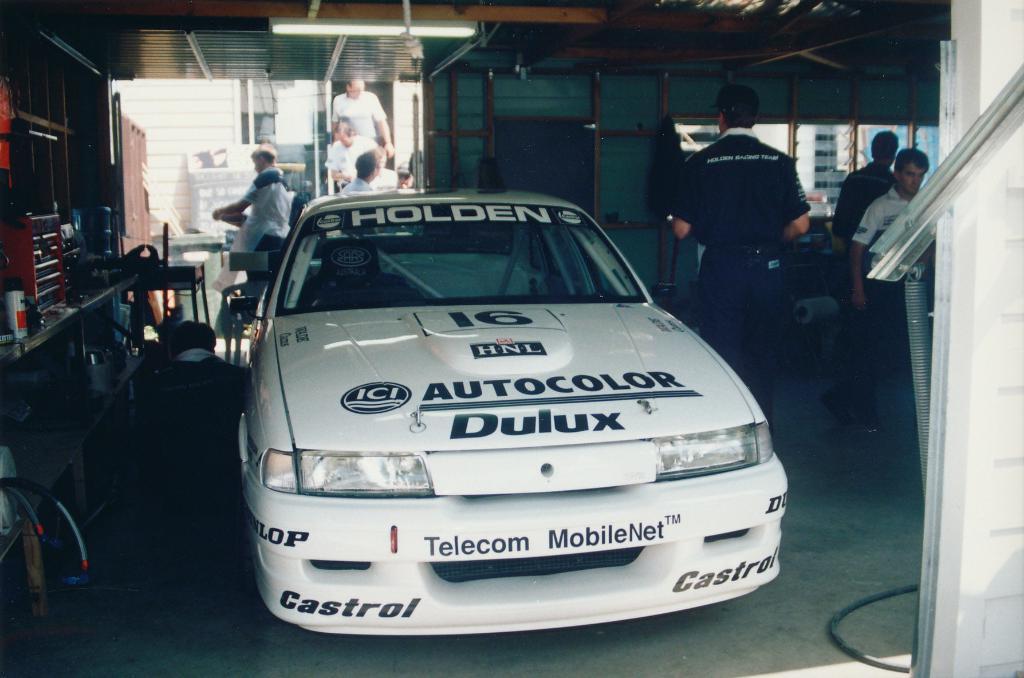In one or two sentences, can you explain what this image depicts? There is a white color vehicle on the floor. on the left side, there is a person, there are some objects on the shelves. On the right side, there are persons standing, there is white wall. In the background, there is a light attached to the roof and there is a building. 